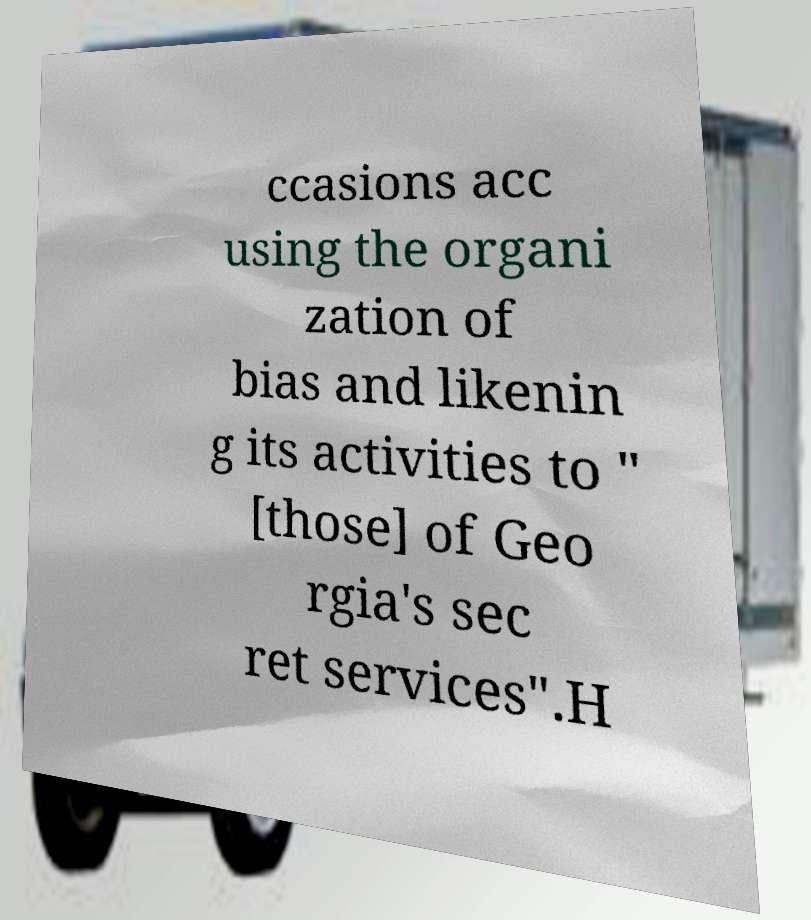What messages or text are displayed in this image? I need them in a readable, typed format. ccasions acc using the organi zation of bias and likenin g its activities to " [those] of Geo rgia's sec ret services".H 